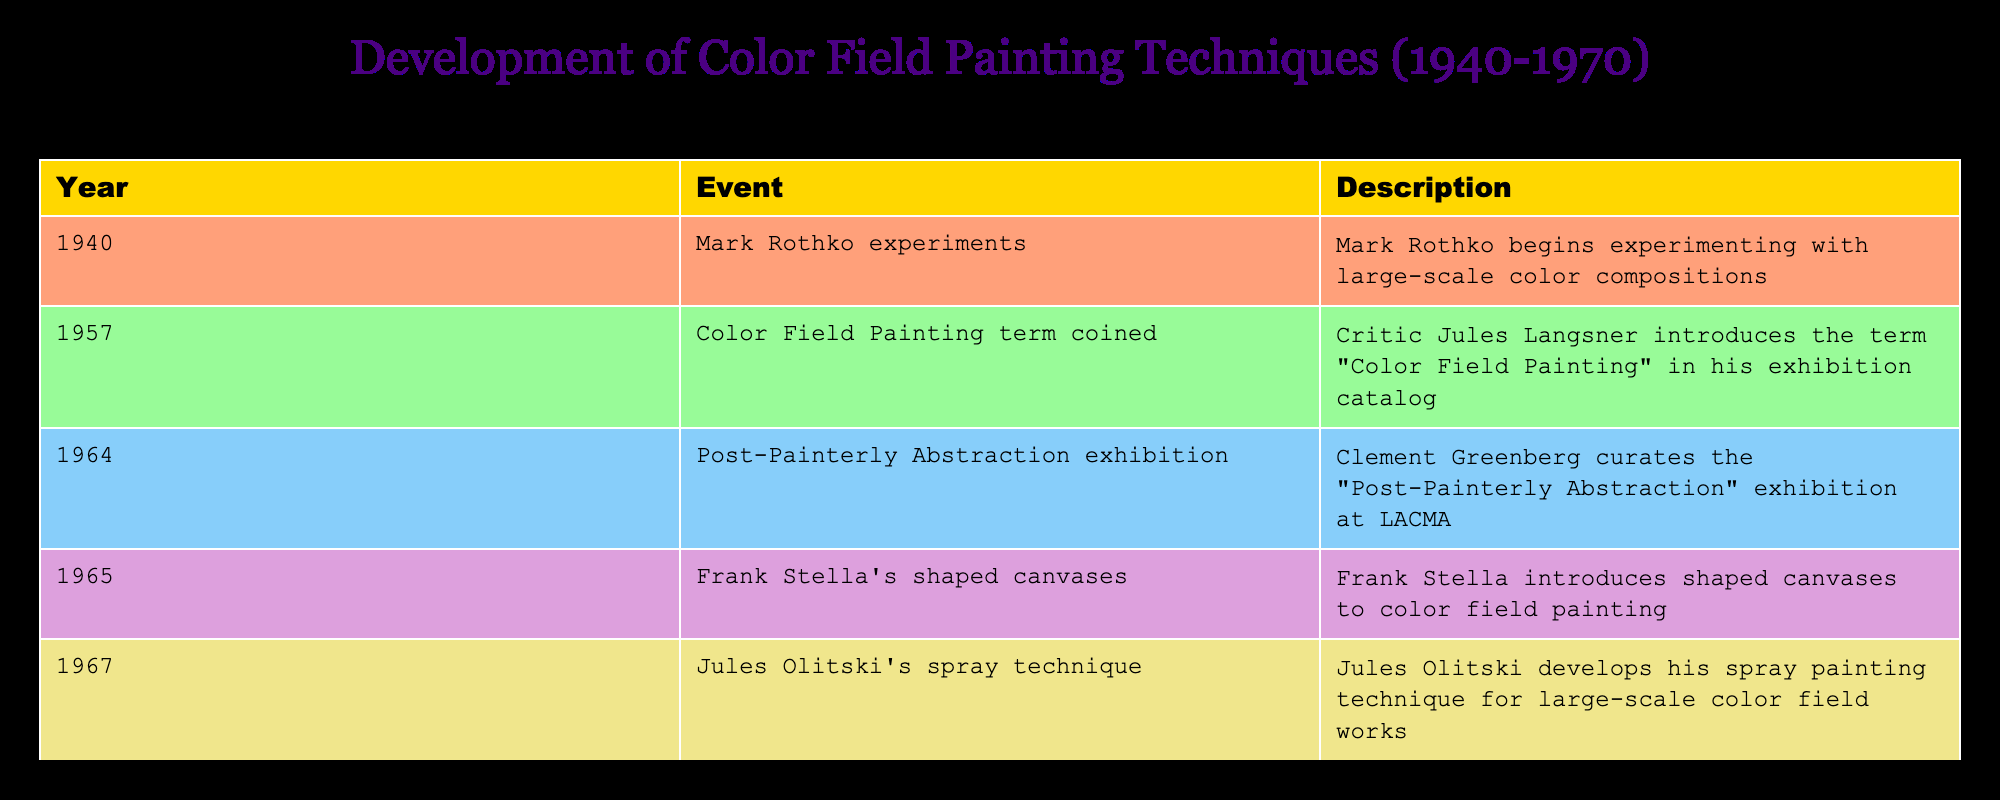What year did Mark Rothko begin experimenting with large-scale color compositions? According to the table, Mark Rothko began his experiments in 1940. This information is directly stated in the event description for that year.
Answer: 1940 Who coined the term "Color Field Painting"? The table indicates that the term "Color Field Painting" was introduced by critic Jules Langsner in 1957, as noted in the description for that year.
Answer: Jules Langsner How many significant events in color field painting occurred between 1960 and 1970? The table lists three significant events in this period: the "Post-Painterly Abstraction" exhibition in 1964, Frank Stella's shaped canvases in 1965, and Jules Olitski's spray technique in 1967. Counting these gives us a total of three events.
Answer: 3 Was the term "Color Field Painting" introduced before or after 1960? The term "Color Field Painting" was coined in 1957, which is indeed before 1960, as per the table's event date.
Answer: Before What is the difference in years between Mark Rothko starting his experiments and the introduction of Jules Olitski's spray technique? Mark Rothko started experimenting in 1940 and Jules Olitski developed his spray technique in 1967. The difference is 1967 - 1940 = 27 years. This calculation considers the years provided in the table.
Answer: 27 years How did the events from 1964 to 1967 in color field painting contribute to its techniques? In the table, two key events occurred from 1964 to 1967: the "Post-Painterly Abstraction" exhibition and the development of Jules Olitski's spray technique. These events introduced significant ideas and methods (the curatorial perspective and the innovative spray technique) that enhanced color field painting. Analyzing these events together highlights how both showcased evolving practices and approaches in the movement.
Answer: They introduced innovative practices Was Frank Stella's introduction of shaped canvases the first major innovation in color field painting after Rothko's initial experiments? The table shows that Frank Stella introduced shaped canvases in 1965, while Rothko's experiments began in 1940, followed by various innovations over the years, such as the 1957 term introduction and the 1964 exhibition. Hence, Frank Stella's innovation is not the first after Rothko, following the introduction of the term and the exhibition.
Answer: No 